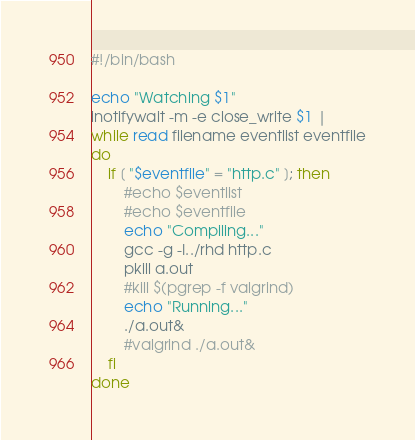Convert code to text. <code><loc_0><loc_0><loc_500><loc_500><_Bash_>#!/bin/bash

echo "Watching $1"
inotifywait -m -e close_write $1 |
while read filename eventlist eventfile
do
	if [ "$eventfile" = "http.c" ]; then
		#echo $eventlist
		#echo $eventfile
		echo "Compiling..."
		gcc -g -I../rhd http.c
		pkill a.out
		#kill $(pgrep -f valgrind)
		echo "Running..."
		./a.out&
		#valgrind ./a.out&
	fi
done
</code> 